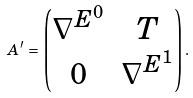Convert formula to latex. <formula><loc_0><loc_0><loc_500><loc_500>A ^ { \prime } \, = \, \begin{pmatrix} \nabla ^ { E ^ { 0 } } & T \\ 0 & \nabla ^ { E ^ { 1 } } \end{pmatrix} .</formula> 